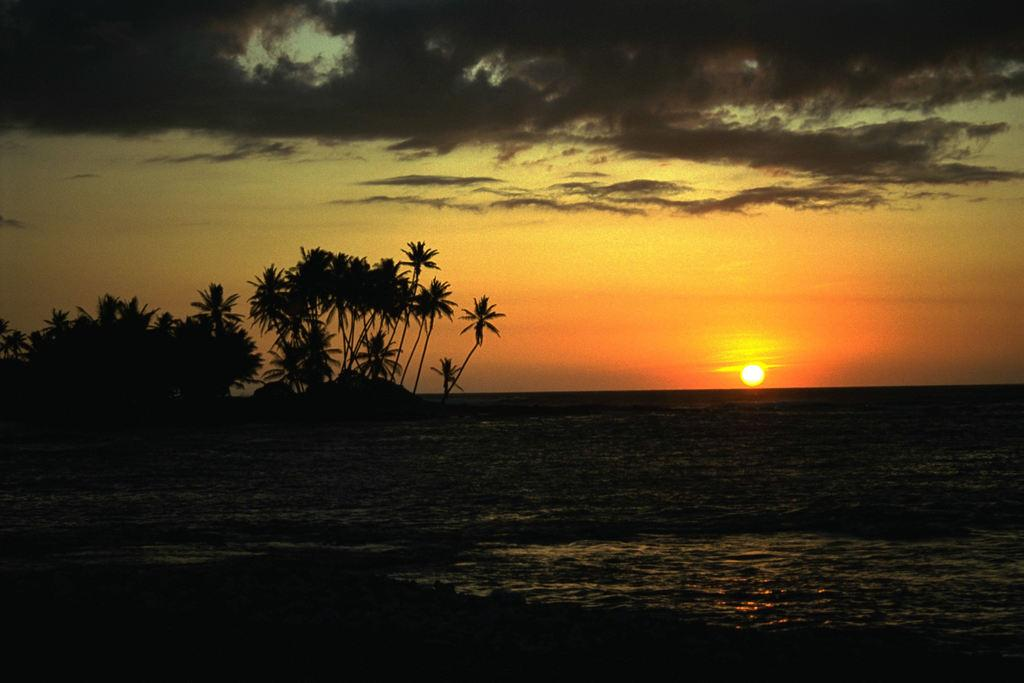What type of vegetation can be seen in the image? There are trees in the image. What natural element is visible in the image? There is water visible in the image. What celestial body can be seen in the background of the image? The sun is visible in the background of the image. What else is visible in the background of the image? The sky is visible in the background of the image. How would you describe the lighting in the image? The image appears to be slightly dark. Can you tell me how many parcels are being delivered by the spy in the image? There is no spy or parcel present in the image. What is the birth date of the baby in the image? There is no baby present in the image. 